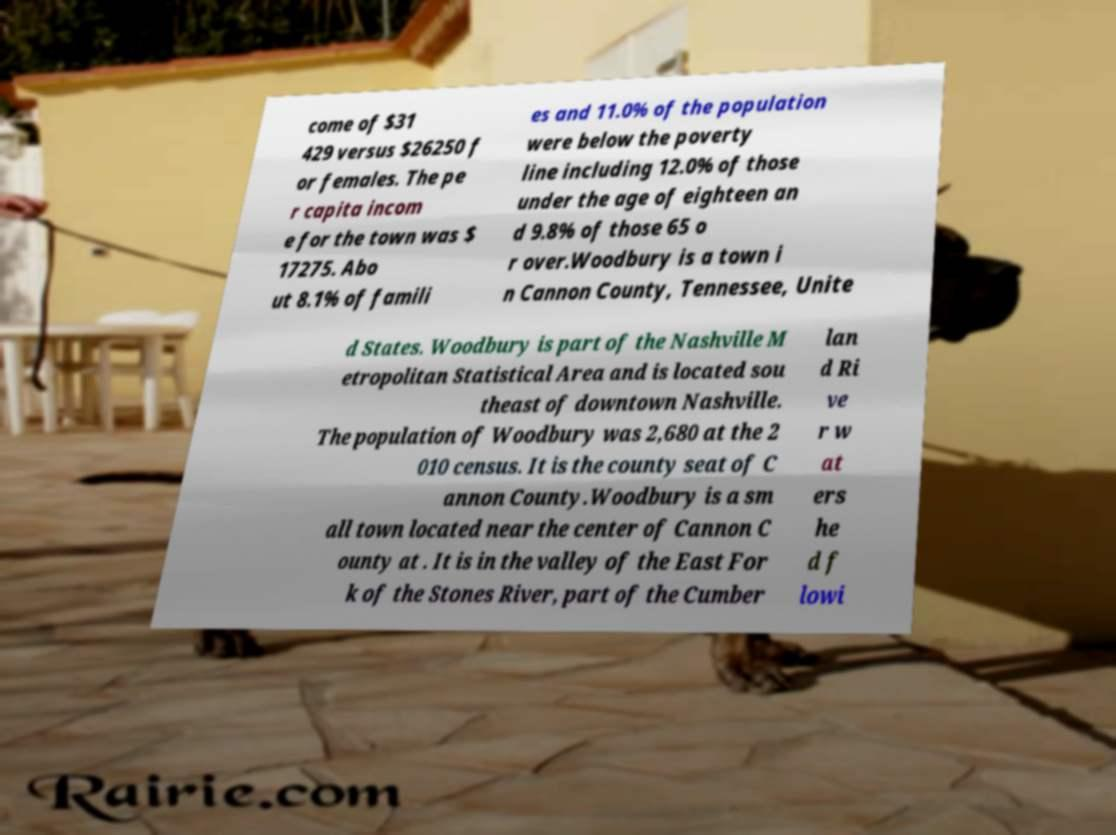Please identify and transcribe the text found in this image. come of $31 429 versus $26250 f or females. The pe r capita incom e for the town was $ 17275. Abo ut 8.1% of famili es and 11.0% of the population were below the poverty line including 12.0% of those under the age of eighteen an d 9.8% of those 65 o r over.Woodbury is a town i n Cannon County, Tennessee, Unite d States. Woodbury is part of the Nashville M etropolitan Statistical Area and is located sou theast of downtown Nashville. The population of Woodbury was 2,680 at the 2 010 census. It is the county seat of C annon County.Woodbury is a sm all town located near the center of Cannon C ounty at . It is in the valley of the East For k of the Stones River, part of the Cumber lan d Ri ve r w at ers he d f lowi 